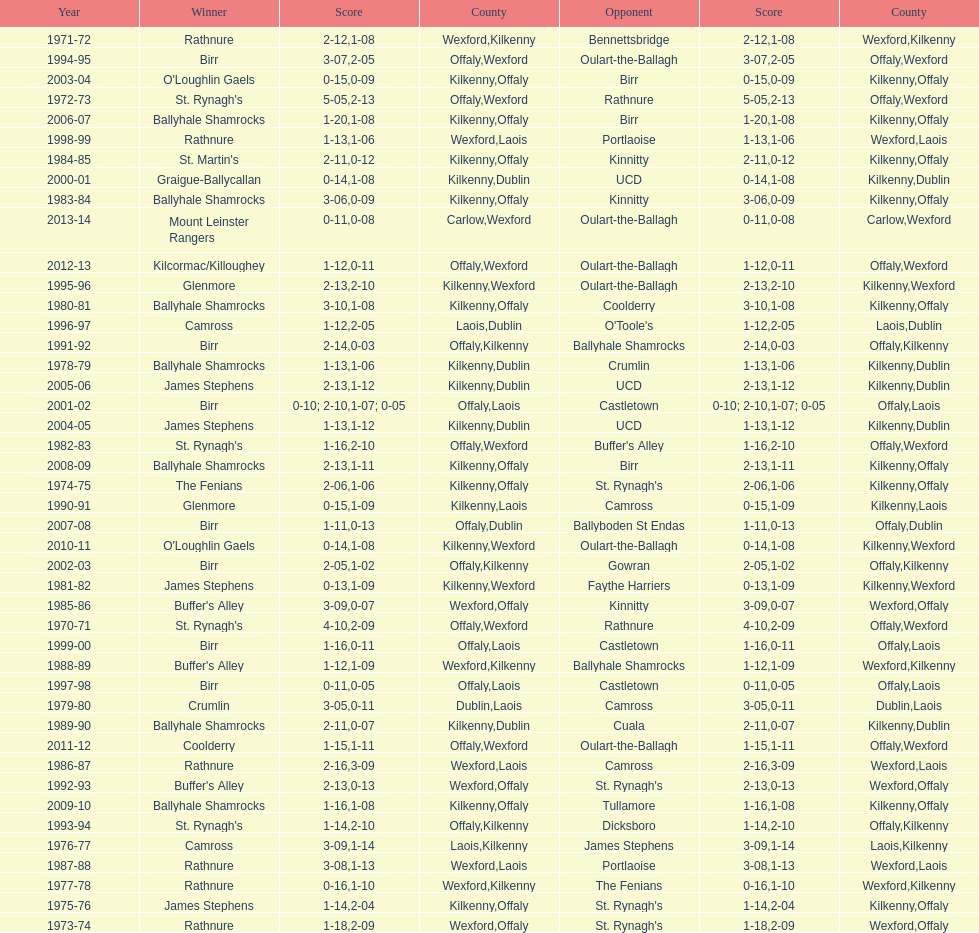James stephens won in 1976-76. who won three years before that? St. Rynagh's. Could you parse the entire table as a dict? {'header': ['Year', 'Winner', 'Score', 'County', 'Opponent', 'Score', 'County'], 'rows': [['1971-72', 'Rathnure', '2-12', 'Wexford', 'Bennettsbridge', '1-08', 'Kilkenny'], ['1994-95', 'Birr', '3-07', 'Offaly', 'Oulart-the-Ballagh', '2-05', 'Wexford'], ['2003-04', "O'Loughlin Gaels", '0-15', 'Kilkenny', 'Birr', '0-09', 'Offaly'], ['1972-73', "St. Rynagh's", '5-05', 'Offaly', 'Rathnure', '2-13', 'Wexford'], ['2006-07', 'Ballyhale Shamrocks', '1-20', 'Kilkenny', 'Birr', '1-08', 'Offaly'], ['1998-99', 'Rathnure', '1-13', 'Wexford', 'Portlaoise', '1-06', 'Laois'], ['1984-85', "St. Martin's", '2-11', 'Kilkenny', 'Kinnitty', '0-12', 'Offaly'], ['2000-01', 'Graigue-Ballycallan', '0-14', 'Kilkenny', 'UCD', '1-08', 'Dublin'], ['1983-84', 'Ballyhale Shamrocks', '3-06', 'Kilkenny', 'Kinnitty', '0-09', 'Offaly'], ['2013-14', 'Mount Leinster Rangers', '0-11', 'Carlow', 'Oulart-the-Ballagh', '0-08', 'Wexford'], ['2012-13', 'Kilcormac/Killoughey', '1-12', 'Offaly', 'Oulart-the-Ballagh', '0-11', 'Wexford'], ['1995-96', 'Glenmore', '2-13', 'Kilkenny', 'Oulart-the-Ballagh', '2-10', 'Wexford'], ['1980-81', 'Ballyhale Shamrocks', '3-10', 'Kilkenny', 'Coolderry', '1-08', 'Offaly'], ['1996-97', 'Camross', '1-12', 'Laois', "O'Toole's", '2-05', 'Dublin'], ['1991-92', 'Birr', '2-14', 'Offaly', 'Ballyhale Shamrocks', '0-03', 'Kilkenny'], ['1978-79', 'Ballyhale Shamrocks', '1-13', 'Kilkenny', 'Crumlin', '1-06', 'Dublin'], ['2005-06', 'James Stephens', '2-13', 'Kilkenny', 'UCD', '1-12', 'Dublin'], ['2001-02', 'Birr', '0-10; 2-10', 'Offaly', 'Castletown', '1-07; 0-05', 'Laois'], ['2004-05', 'James Stephens', '1-13', 'Kilkenny', 'UCD', '1-12', 'Dublin'], ['1982-83', "St. Rynagh's", '1-16', 'Offaly', "Buffer's Alley", '2-10', 'Wexford'], ['2008-09', 'Ballyhale Shamrocks', '2-13', 'Kilkenny', 'Birr', '1-11', 'Offaly'], ['1974-75', 'The Fenians', '2-06', 'Kilkenny', "St. Rynagh's", '1-06', 'Offaly'], ['1990-91', 'Glenmore', '0-15', 'Kilkenny', 'Camross', '1-09', 'Laois'], ['2007-08', 'Birr', '1-11', 'Offaly', 'Ballyboden St Endas', '0-13', 'Dublin'], ['2010-11', "O'Loughlin Gaels", '0-14', 'Kilkenny', 'Oulart-the-Ballagh', '1-08', 'Wexford'], ['2002-03', 'Birr', '2-05', 'Offaly', 'Gowran', '1-02', 'Kilkenny'], ['1981-82', 'James Stephens', '0-13', 'Kilkenny', 'Faythe Harriers', '1-09', 'Wexford'], ['1985-86', "Buffer's Alley", '3-09', 'Wexford', 'Kinnitty', '0-07', 'Offaly'], ['1970-71', "St. Rynagh's", '4-10', 'Offaly', 'Rathnure', '2-09', 'Wexford'], ['1999-00', 'Birr', '1-16', 'Offaly', 'Castletown', '0-11', 'Laois'], ['1988-89', "Buffer's Alley", '1-12', 'Wexford', 'Ballyhale Shamrocks', '1-09', 'Kilkenny'], ['1997-98', 'Birr', '0-11', 'Offaly', 'Castletown', '0-05', 'Laois'], ['1979-80', 'Crumlin', '3-05', 'Dublin', 'Camross', '0-11', 'Laois'], ['1989-90', 'Ballyhale Shamrocks', '2-11', 'Kilkenny', 'Cuala', '0-07', 'Dublin'], ['2011-12', 'Coolderry', '1-15', 'Offaly', 'Oulart-the-Ballagh', '1-11', 'Wexford'], ['1986-87', 'Rathnure', '2-16', 'Wexford', 'Camross', '3-09', 'Laois'], ['1992-93', "Buffer's Alley", '2-13', 'Wexford', "St. Rynagh's", '0-13', 'Offaly'], ['2009-10', 'Ballyhale Shamrocks', '1-16', 'Kilkenny', 'Tullamore', '1-08', 'Offaly'], ['1993-94', "St. Rynagh's", '1-14', 'Offaly', 'Dicksboro', '2-10', 'Kilkenny'], ['1976-77', 'Camross', '3-09', 'Laois', 'James Stephens', '1-14', 'Kilkenny'], ['1987-88', 'Rathnure', '3-08', 'Wexford', 'Portlaoise', '1-13', 'Laois'], ['1977-78', 'Rathnure', '0-16', 'Wexford', 'The Fenians', '1-10', 'Kilkenny'], ['1975-76', 'James Stephens', '1-14', 'Kilkenny', "St. Rynagh's", '2-04', 'Offaly'], ['1973-74', 'Rathnure', '1-18', 'Wexford', "St. Rynagh's", '2-09', 'Offaly']]} 